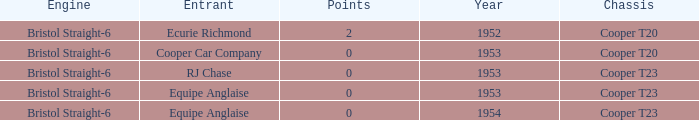Which entrant was present prior to 1953? Ecurie Richmond. 